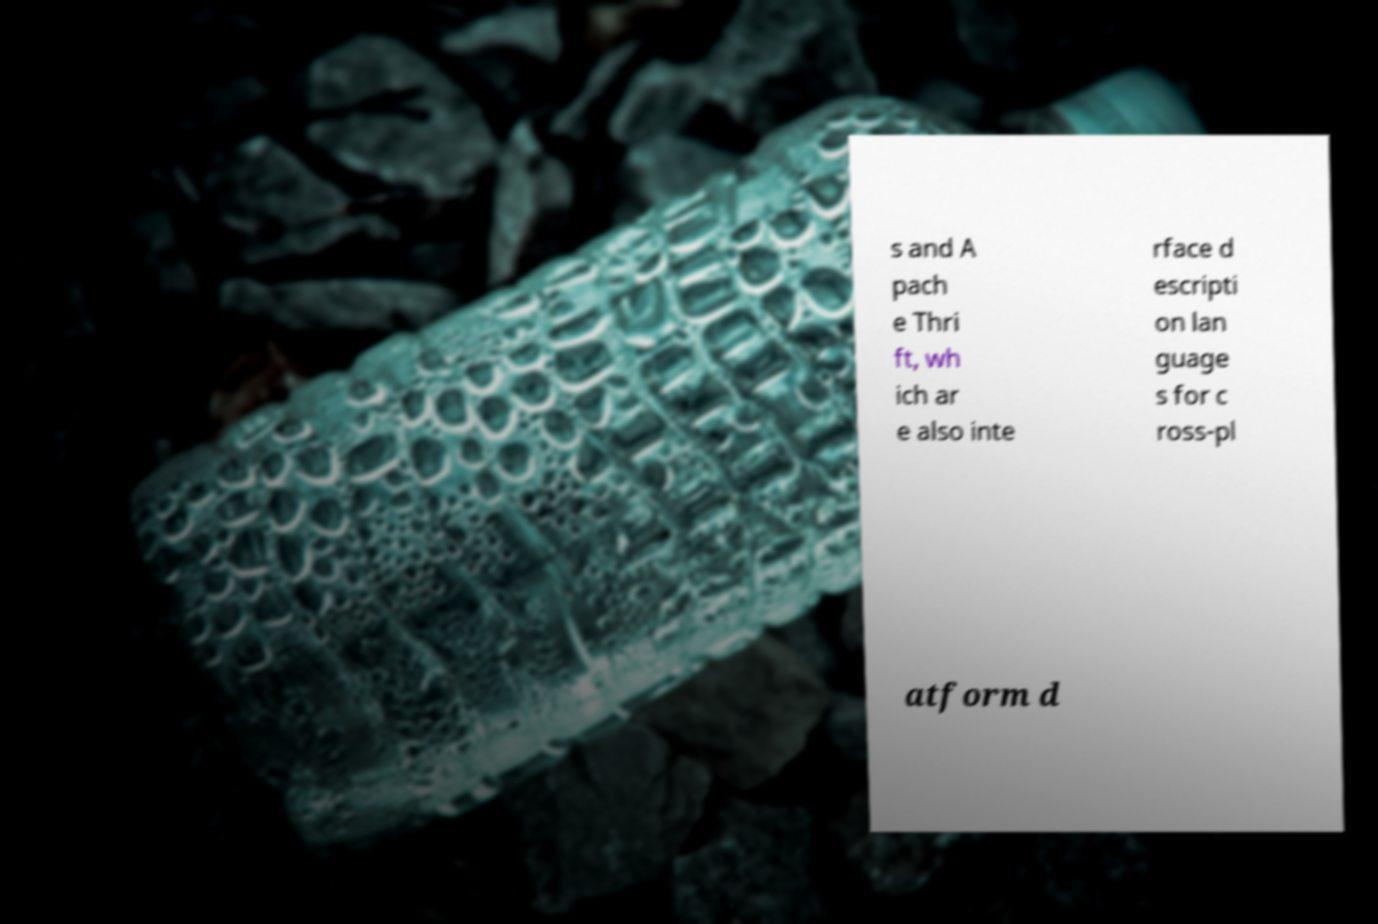There's text embedded in this image that I need extracted. Can you transcribe it verbatim? s and A pach e Thri ft, wh ich ar e also inte rface d escripti on lan guage s for c ross-pl atform d 